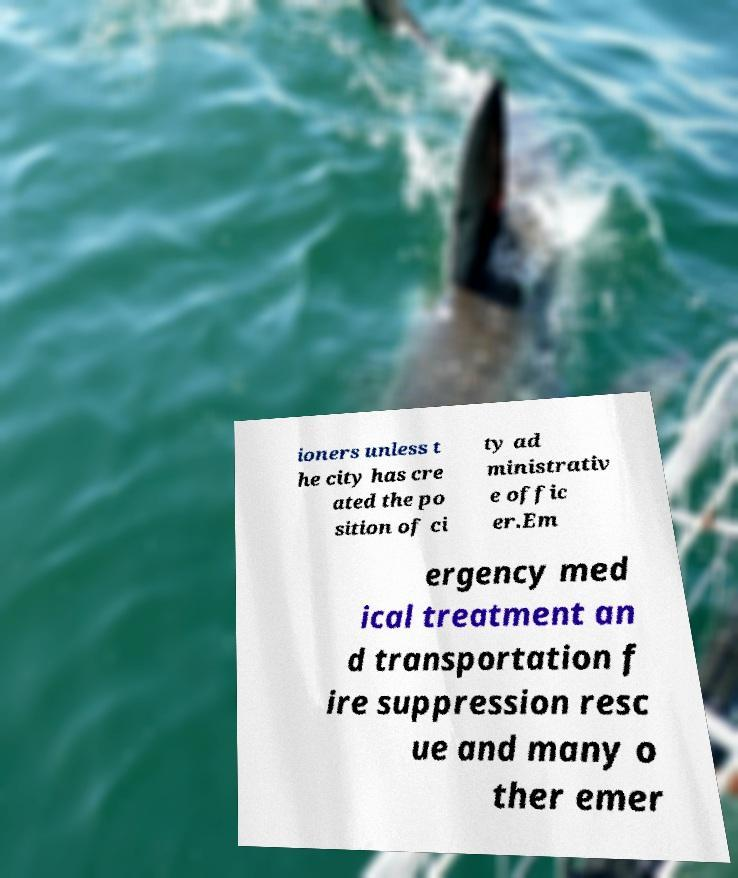Can you accurately transcribe the text from the provided image for me? ioners unless t he city has cre ated the po sition of ci ty ad ministrativ e offic er.Em ergency med ical treatment an d transportation f ire suppression resc ue and many o ther emer 